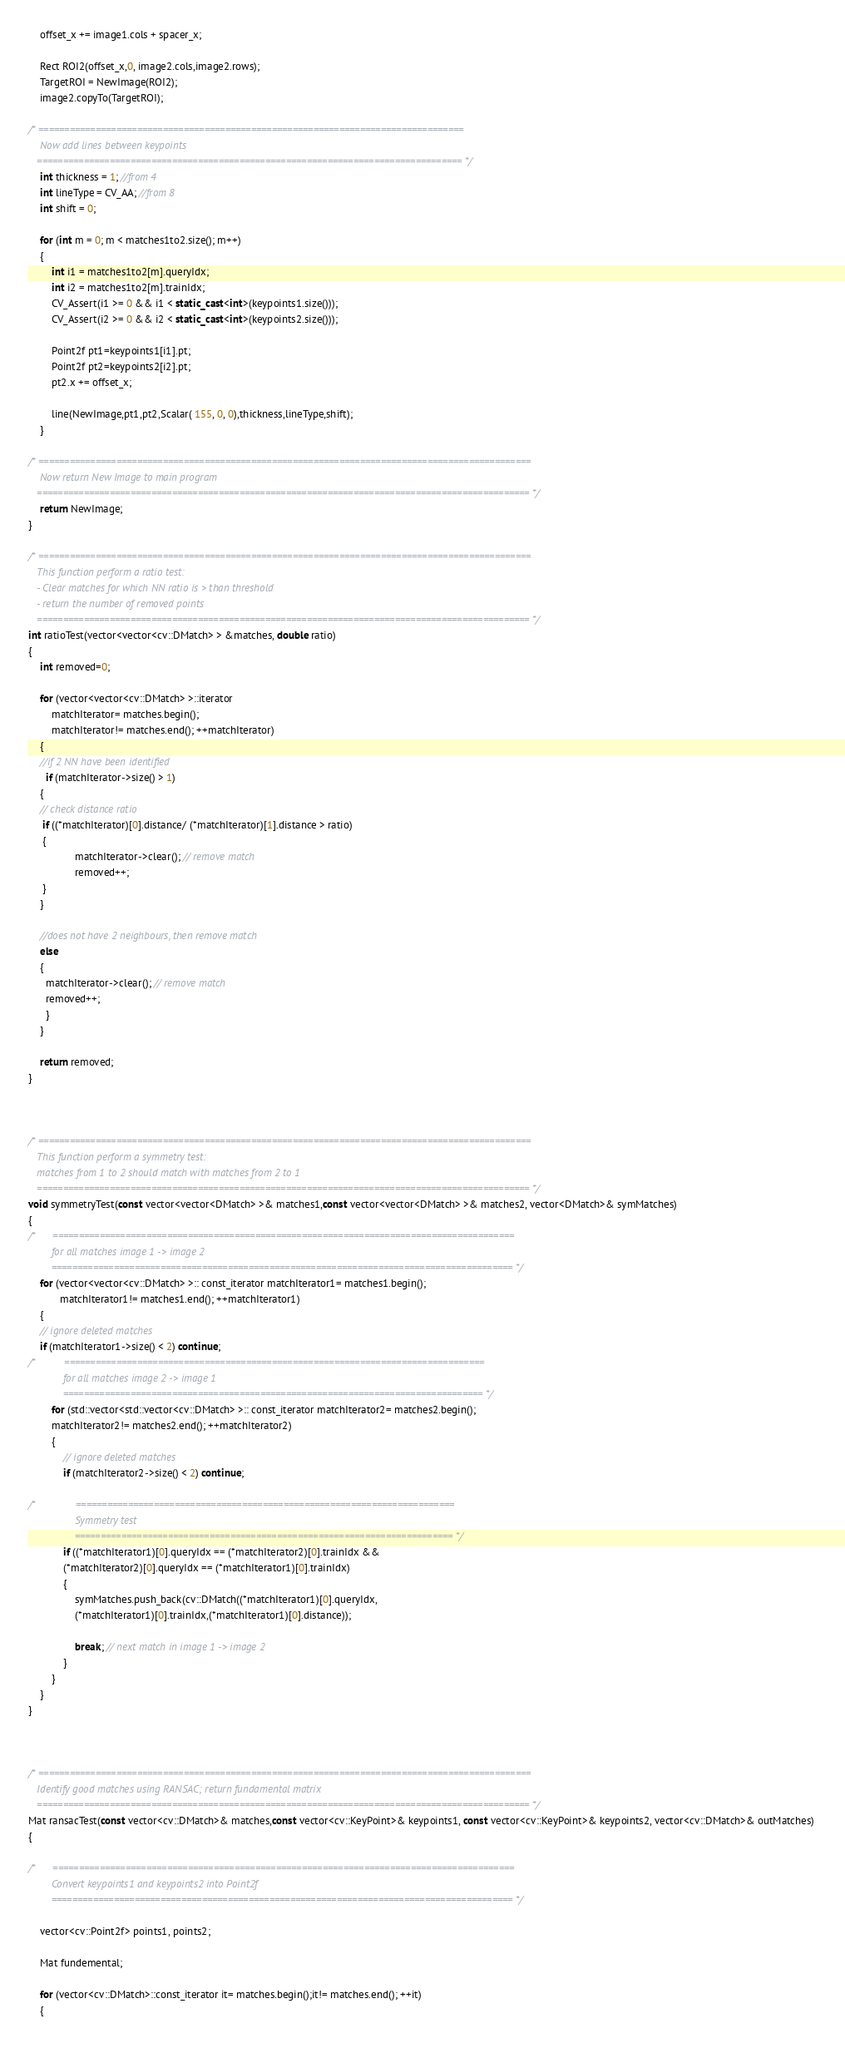<code> <loc_0><loc_0><loc_500><loc_500><_C++_>	offset_x += image1.cols + spacer_x;

	Rect ROI2(offset_x,0, image2.cols,image2.rows);
	TargetROI = NewImage(ROI2);
	image2.copyTo(TargetROI);

/* ==================================================================================
	Now add lines between keypoints
   ================================================================================== */
	int thickness = 1; //from 4
	int lineType = CV_AA; //from 8
	int shift = 0;

	for (int m = 0; m < matches1to2.size(); m++)
	{
		int i1 = matches1to2[m].queryIdx;
		int i2 = matches1to2[m].trainIdx;
		CV_Assert(i1 >= 0 && i1 < static_cast<int>(keypoints1.size()));
		CV_Assert(i2 >= 0 && i2 < static_cast<int>(keypoints2.size()));

		Point2f pt1=keypoints1[i1].pt;
		Point2f pt2=keypoints2[i2].pt;
		pt2.x += offset_x;

		line(NewImage,pt1,pt2,Scalar( 155, 0, 0),thickness,lineType,shift);
	}

/* ===============================================================================================
	Now return New Image to main program
   =============================================================================================== */
	return NewImage;
}

/* ===============================================================================================
   This function perform a ratio test: 
   - Clear matches for which NN ratio is > than threshold
   - return the number of removed points
   =============================================================================================== */
int ratioTest(vector<vector<cv::DMatch> > &matches, double ratio) 
{
	int removed=0;

	for (vector<vector<cv::DMatch> >::iterator
		matchIterator= matches.begin();
		matchIterator!= matches.end(); ++matchIterator) 
	{
    //if 2 NN have been identified
	  if (matchIterator->size() > 1)
    {
    // check distance ratio
   	 if ((*matchIterator)[0].distance/ (*matchIterator)[1].distance > ratio) 
     {
				matchIterator->clear(); // remove match
				removed++;
     }
    } 

    //does not have 2 neighbours, then remove match
    else 
    {
  	  matchIterator->clear(); // remove match
  	  removed++;
	  }
	}

	return removed;
}



/* ===============================================================================================
   This function perform a symmetry test:
   matches from 1 to 2 should match with matches from 2 to 1
   =============================================================================================== */
void symmetryTest(const vector<vector<DMatch> >& matches1,const vector<vector<DMatch> >& matches2, vector<DMatch>& symMatches) 
{
/*    	=========================================================================================
        for all matches image 1 -> image 2
       	========================================================================================= */
	for (vector<vector<cv::DMatch> >:: const_iterator matchIterator1= matches1.begin();
           matchIterator1!= matches1.end(); ++matchIterator1) 
	{
    // ignore deleted matches
  	if (matchIterator1->size() < 2) continue;
/*     		=================================================================================
        	for all matches image 2 -> image 1
       		================================================================================= */
		for (std::vector<std::vector<cv::DMatch> >:: const_iterator matchIterator2= matches2.begin();
		matchIterator2!= matches2.end(); ++matchIterator2) 
		{
			// ignore deleted matches
			if (matchIterator2->size() < 2) continue;

/*     			=========================================================================
        		Symmetry test
       			========================================================================= */
			if ((*matchIterator1)[0].queryIdx == (*matchIterator2)[0].trainIdx &&
			(*matchIterator2)[0].queryIdx == (*matchIterator1)[0].trainIdx) 
			{
				symMatches.push_back(cv::DMatch((*matchIterator1)[0].queryIdx,
				(*matchIterator1)[0].trainIdx,(*matchIterator1)[0].distance));

				break; // next match in image 1 -> image 2
			}
		}
	}
}



/* ===============================================================================================
   Identify good matches using RANSAC; return fundamental matrix
   =============================================================================================== */
Mat ransacTest(const vector<cv::DMatch>& matches,const vector<cv::KeyPoint>& keypoints1, const vector<cv::KeyPoint>& keypoints2, vector<cv::DMatch>& outMatches) 
{

/*     	=========================================================================================
        Convert keypoints1 and keypoints2 into Point2f
       	========================================================================================= */

	vector<cv::Point2f> points1, points2;

	Mat fundemental;

	for (vector<cv::DMatch>::const_iterator it= matches.begin();it!= matches.end(); ++it) 
	{
</code> 